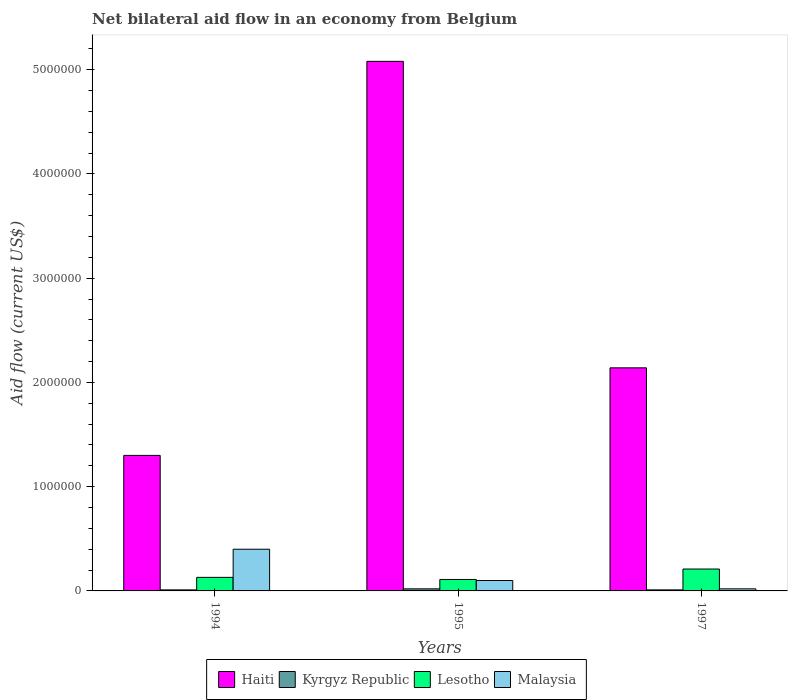Are the number of bars on each tick of the X-axis equal?
Provide a short and direct response. Yes. How many bars are there on the 3rd tick from the left?
Provide a succinct answer. 4. How many bars are there on the 3rd tick from the right?
Offer a very short reply. 4. Across all years, what is the minimum net bilateral aid flow in Kyrgyz Republic?
Offer a terse response. 10000. In which year was the net bilateral aid flow in Malaysia maximum?
Keep it short and to the point. 1994. In which year was the net bilateral aid flow in Lesotho minimum?
Your answer should be very brief. 1995. What is the difference between the net bilateral aid flow in Kyrgyz Republic in 1994 and the net bilateral aid flow in Haiti in 1995?
Ensure brevity in your answer.  -5.07e+06. What is the average net bilateral aid flow in Malaysia per year?
Provide a succinct answer. 1.73e+05. In the year 1995, what is the difference between the net bilateral aid flow in Haiti and net bilateral aid flow in Malaysia?
Your response must be concise. 4.98e+06. In how many years, is the net bilateral aid flow in Malaysia greater than 4200000 US$?
Give a very brief answer. 0. What is the ratio of the net bilateral aid flow in Haiti in 1995 to that in 1997?
Make the answer very short. 2.37. Is the net bilateral aid flow in Kyrgyz Republic in 1994 less than that in 1997?
Offer a very short reply. No. What is the difference between the highest and the second highest net bilateral aid flow in Kyrgyz Republic?
Offer a terse response. 10000. What is the difference between the highest and the lowest net bilateral aid flow in Lesotho?
Provide a succinct answer. 1.00e+05. In how many years, is the net bilateral aid flow in Kyrgyz Republic greater than the average net bilateral aid flow in Kyrgyz Republic taken over all years?
Provide a short and direct response. 1. Is the sum of the net bilateral aid flow in Lesotho in 1994 and 1997 greater than the maximum net bilateral aid flow in Haiti across all years?
Provide a short and direct response. No. What does the 1st bar from the left in 1994 represents?
Your response must be concise. Haiti. What does the 1st bar from the right in 1994 represents?
Keep it short and to the point. Malaysia. How many bars are there?
Your response must be concise. 12. Are all the bars in the graph horizontal?
Provide a succinct answer. No. How many years are there in the graph?
Ensure brevity in your answer.  3. What is the difference between two consecutive major ticks on the Y-axis?
Provide a succinct answer. 1.00e+06. Are the values on the major ticks of Y-axis written in scientific E-notation?
Provide a short and direct response. No. Does the graph contain any zero values?
Your answer should be very brief. No. Does the graph contain grids?
Provide a short and direct response. No. Where does the legend appear in the graph?
Give a very brief answer. Bottom center. What is the title of the graph?
Your answer should be compact. Net bilateral aid flow in an economy from Belgium. Does "Pakistan" appear as one of the legend labels in the graph?
Ensure brevity in your answer.  No. What is the label or title of the Y-axis?
Offer a very short reply. Aid flow (current US$). What is the Aid flow (current US$) in Haiti in 1994?
Provide a succinct answer. 1.30e+06. What is the Aid flow (current US$) in Lesotho in 1994?
Your response must be concise. 1.30e+05. What is the Aid flow (current US$) in Malaysia in 1994?
Ensure brevity in your answer.  4.00e+05. What is the Aid flow (current US$) of Haiti in 1995?
Ensure brevity in your answer.  5.08e+06. What is the Aid flow (current US$) in Kyrgyz Republic in 1995?
Your answer should be compact. 2.00e+04. What is the Aid flow (current US$) in Lesotho in 1995?
Ensure brevity in your answer.  1.10e+05. What is the Aid flow (current US$) in Haiti in 1997?
Your response must be concise. 2.14e+06. Across all years, what is the maximum Aid flow (current US$) in Haiti?
Ensure brevity in your answer.  5.08e+06. Across all years, what is the maximum Aid flow (current US$) in Lesotho?
Your answer should be compact. 2.10e+05. Across all years, what is the minimum Aid flow (current US$) of Haiti?
Offer a terse response. 1.30e+06. Across all years, what is the minimum Aid flow (current US$) of Kyrgyz Republic?
Your response must be concise. 10000. Across all years, what is the minimum Aid flow (current US$) of Lesotho?
Keep it short and to the point. 1.10e+05. Across all years, what is the minimum Aid flow (current US$) of Malaysia?
Your answer should be compact. 2.00e+04. What is the total Aid flow (current US$) in Haiti in the graph?
Keep it short and to the point. 8.52e+06. What is the total Aid flow (current US$) of Kyrgyz Republic in the graph?
Provide a succinct answer. 4.00e+04. What is the total Aid flow (current US$) of Lesotho in the graph?
Provide a short and direct response. 4.50e+05. What is the total Aid flow (current US$) in Malaysia in the graph?
Your response must be concise. 5.20e+05. What is the difference between the Aid flow (current US$) in Haiti in 1994 and that in 1995?
Make the answer very short. -3.78e+06. What is the difference between the Aid flow (current US$) of Kyrgyz Republic in 1994 and that in 1995?
Give a very brief answer. -10000. What is the difference between the Aid flow (current US$) of Haiti in 1994 and that in 1997?
Your answer should be very brief. -8.40e+05. What is the difference between the Aid flow (current US$) in Kyrgyz Republic in 1994 and that in 1997?
Ensure brevity in your answer.  0. What is the difference between the Aid flow (current US$) in Lesotho in 1994 and that in 1997?
Keep it short and to the point. -8.00e+04. What is the difference between the Aid flow (current US$) of Malaysia in 1994 and that in 1997?
Provide a succinct answer. 3.80e+05. What is the difference between the Aid flow (current US$) in Haiti in 1995 and that in 1997?
Your response must be concise. 2.94e+06. What is the difference between the Aid flow (current US$) of Kyrgyz Republic in 1995 and that in 1997?
Provide a short and direct response. 10000. What is the difference between the Aid flow (current US$) in Lesotho in 1995 and that in 1997?
Provide a succinct answer. -1.00e+05. What is the difference between the Aid flow (current US$) of Malaysia in 1995 and that in 1997?
Offer a terse response. 8.00e+04. What is the difference between the Aid flow (current US$) in Haiti in 1994 and the Aid flow (current US$) in Kyrgyz Republic in 1995?
Offer a very short reply. 1.28e+06. What is the difference between the Aid flow (current US$) of Haiti in 1994 and the Aid flow (current US$) of Lesotho in 1995?
Offer a very short reply. 1.19e+06. What is the difference between the Aid flow (current US$) of Haiti in 1994 and the Aid flow (current US$) of Malaysia in 1995?
Make the answer very short. 1.20e+06. What is the difference between the Aid flow (current US$) of Lesotho in 1994 and the Aid flow (current US$) of Malaysia in 1995?
Make the answer very short. 3.00e+04. What is the difference between the Aid flow (current US$) of Haiti in 1994 and the Aid flow (current US$) of Kyrgyz Republic in 1997?
Keep it short and to the point. 1.29e+06. What is the difference between the Aid flow (current US$) in Haiti in 1994 and the Aid flow (current US$) in Lesotho in 1997?
Keep it short and to the point. 1.09e+06. What is the difference between the Aid flow (current US$) of Haiti in 1994 and the Aid flow (current US$) of Malaysia in 1997?
Your answer should be very brief. 1.28e+06. What is the difference between the Aid flow (current US$) of Kyrgyz Republic in 1994 and the Aid flow (current US$) of Malaysia in 1997?
Ensure brevity in your answer.  -10000. What is the difference between the Aid flow (current US$) in Haiti in 1995 and the Aid flow (current US$) in Kyrgyz Republic in 1997?
Give a very brief answer. 5.07e+06. What is the difference between the Aid flow (current US$) of Haiti in 1995 and the Aid flow (current US$) of Lesotho in 1997?
Provide a succinct answer. 4.87e+06. What is the difference between the Aid flow (current US$) in Haiti in 1995 and the Aid flow (current US$) in Malaysia in 1997?
Your answer should be very brief. 5.06e+06. What is the difference between the Aid flow (current US$) of Kyrgyz Republic in 1995 and the Aid flow (current US$) of Malaysia in 1997?
Keep it short and to the point. 0. What is the average Aid flow (current US$) in Haiti per year?
Give a very brief answer. 2.84e+06. What is the average Aid flow (current US$) of Kyrgyz Republic per year?
Offer a very short reply. 1.33e+04. What is the average Aid flow (current US$) in Lesotho per year?
Provide a succinct answer. 1.50e+05. What is the average Aid flow (current US$) of Malaysia per year?
Ensure brevity in your answer.  1.73e+05. In the year 1994, what is the difference between the Aid flow (current US$) in Haiti and Aid flow (current US$) in Kyrgyz Republic?
Ensure brevity in your answer.  1.29e+06. In the year 1994, what is the difference between the Aid flow (current US$) of Haiti and Aid flow (current US$) of Lesotho?
Keep it short and to the point. 1.17e+06. In the year 1994, what is the difference between the Aid flow (current US$) in Kyrgyz Republic and Aid flow (current US$) in Lesotho?
Give a very brief answer. -1.20e+05. In the year 1994, what is the difference between the Aid flow (current US$) of Kyrgyz Republic and Aid flow (current US$) of Malaysia?
Keep it short and to the point. -3.90e+05. In the year 1995, what is the difference between the Aid flow (current US$) in Haiti and Aid flow (current US$) in Kyrgyz Republic?
Offer a terse response. 5.06e+06. In the year 1995, what is the difference between the Aid flow (current US$) in Haiti and Aid flow (current US$) in Lesotho?
Ensure brevity in your answer.  4.97e+06. In the year 1995, what is the difference between the Aid flow (current US$) of Haiti and Aid flow (current US$) of Malaysia?
Provide a short and direct response. 4.98e+06. In the year 1997, what is the difference between the Aid flow (current US$) in Haiti and Aid flow (current US$) in Kyrgyz Republic?
Provide a succinct answer. 2.13e+06. In the year 1997, what is the difference between the Aid flow (current US$) of Haiti and Aid flow (current US$) of Lesotho?
Your answer should be compact. 1.93e+06. In the year 1997, what is the difference between the Aid flow (current US$) in Haiti and Aid flow (current US$) in Malaysia?
Provide a succinct answer. 2.12e+06. In the year 1997, what is the difference between the Aid flow (current US$) in Kyrgyz Republic and Aid flow (current US$) in Lesotho?
Your answer should be very brief. -2.00e+05. What is the ratio of the Aid flow (current US$) in Haiti in 1994 to that in 1995?
Provide a short and direct response. 0.26. What is the ratio of the Aid flow (current US$) in Kyrgyz Republic in 1994 to that in 1995?
Provide a succinct answer. 0.5. What is the ratio of the Aid flow (current US$) in Lesotho in 1994 to that in 1995?
Your response must be concise. 1.18. What is the ratio of the Aid flow (current US$) in Haiti in 1994 to that in 1997?
Your answer should be compact. 0.61. What is the ratio of the Aid flow (current US$) of Lesotho in 1994 to that in 1997?
Offer a very short reply. 0.62. What is the ratio of the Aid flow (current US$) in Haiti in 1995 to that in 1997?
Provide a succinct answer. 2.37. What is the ratio of the Aid flow (current US$) of Kyrgyz Republic in 1995 to that in 1997?
Your response must be concise. 2. What is the ratio of the Aid flow (current US$) of Lesotho in 1995 to that in 1997?
Provide a succinct answer. 0.52. What is the difference between the highest and the second highest Aid flow (current US$) in Haiti?
Ensure brevity in your answer.  2.94e+06. What is the difference between the highest and the second highest Aid flow (current US$) of Kyrgyz Republic?
Provide a succinct answer. 10000. What is the difference between the highest and the second highest Aid flow (current US$) of Lesotho?
Provide a succinct answer. 8.00e+04. What is the difference between the highest and the lowest Aid flow (current US$) in Haiti?
Give a very brief answer. 3.78e+06. What is the difference between the highest and the lowest Aid flow (current US$) of Lesotho?
Give a very brief answer. 1.00e+05. What is the difference between the highest and the lowest Aid flow (current US$) in Malaysia?
Offer a very short reply. 3.80e+05. 